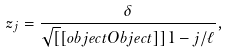<formula> <loc_0><loc_0><loc_500><loc_500>z _ { j } = \frac { \delta } { \sqrt { [ } [ o b j e c t O b j e c t ] ] 1 - j / \ell } ,</formula> 